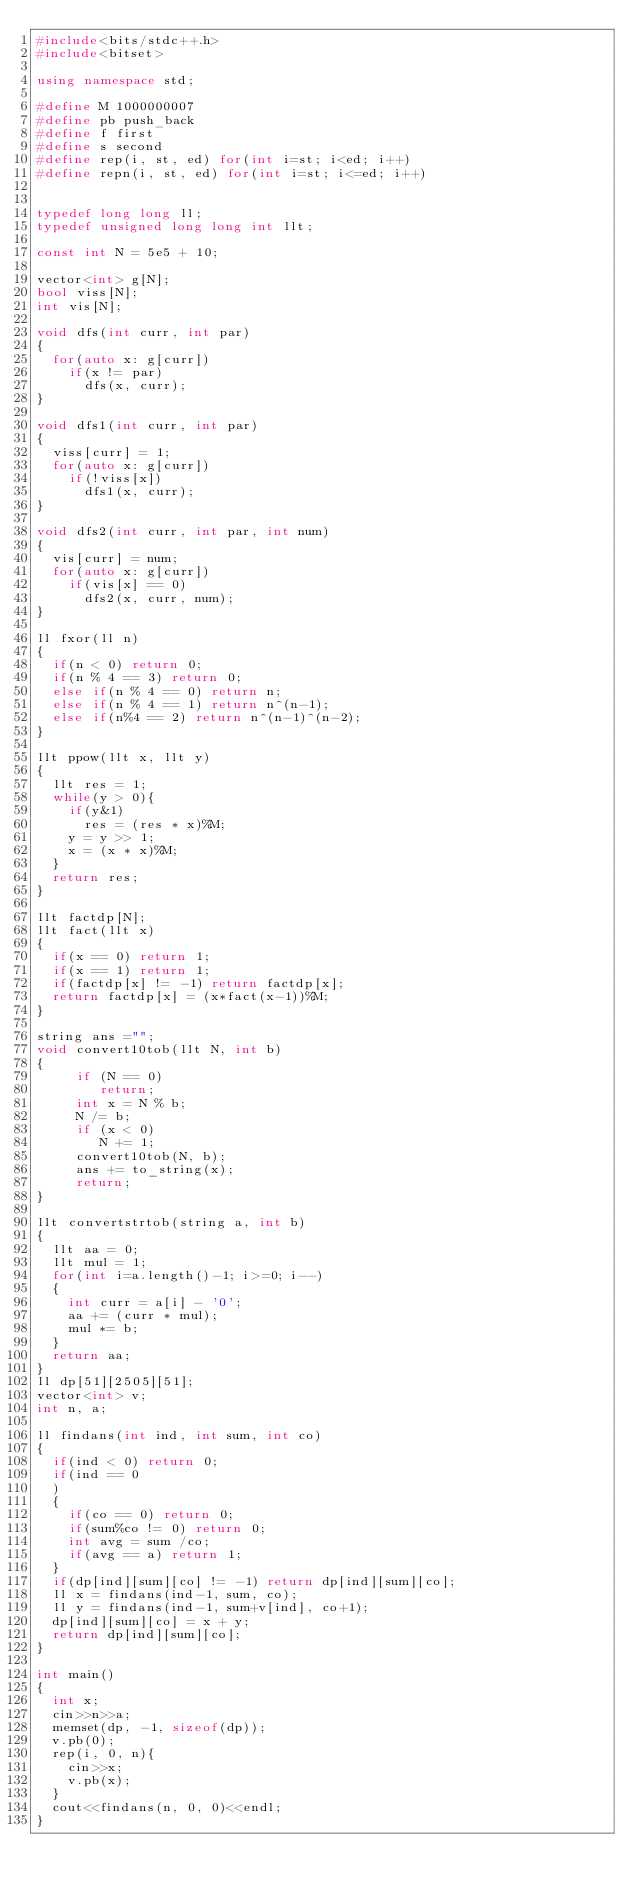Convert code to text. <code><loc_0><loc_0><loc_500><loc_500><_C++_>#include<bits/stdc++.h>
#include<bitset>

using namespace std;

#define M 1000000007
#define pb push_back
#define f first
#define s second
#define rep(i, st, ed) for(int i=st; i<ed; i++)
#define repn(i, st, ed) for(int i=st; i<=ed; i++)


typedef long long ll;
typedef unsigned long long int llt;

const int N = 5e5 + 10;

vector<int> g[N];
bool viss[N];
int vis[N];

void dfs(int curr, int par)
{
  for(auto x: g[curr])
    if(x != par)
      dfs(x, curr);
}

void dfs1(int curr, int par)
{
  viss[curr] = 1;
  for(auto x: g[curr])
    if(!viss[x])
      dfs1(x, curr);
}

void dfs2(int curr, int par, int num)
{
  vis[curr] = num;
  for(auto x: g[curr])
    if(vis[x] == 0)
      dfs2(x, curr, num);
}

ll fxor(ll n)
{
  if(n < 0) return 0;
  if(n % 4 == 3) return 0;
  else if(n % 4 == 0) return n;
  else if(n % 4 == 1) return n^(n-1);
  else if(n%4 == 2) return n^(n-1)^(n-2);
}

llt ppow(llt x, llt y)
{
  llt res = 1;
  while(y > 0){
    if(y&1)
      res = (res * x)%M;
    y = y >> 1;
    x = (x * x)%M;
  }
  return res;
}

llt factdp[N];
llt fact(llt x)
{
  if(x == 0) return 1;
  if(x == 1) return 1;
  if(factdp[x] != -1) return factdp[x];
  return factdp[x] = (x*fact(x-1))%M;
}

string ans ="";
void convert10tob(llt N, int b)
{
     if (N == 0)
        return;
     int x = N % b;
     N /= b;
     if (x < 0)
        N += 1;
     convert10tob(N, b);
     ans += to_string(x);
     return;
}

llt convertstrtob(string a, int b)
{
  llt aa = 0;
  llt mul = 1;
  for(int i=a.length()-1; i>=0; i--)
  {
    int curr = a[i] - '0';
    aa += (curr * mul);
    mul *= b;
  }
  return aa;
}
ll dp[51][2505][51];
vector<int> v;
int n, a;

ll findans(int ind, int sum, int co)
{
  if(ind < 0) return 0;
  if(ind == 0
  )
  {
    if(co == 0) return 0;
    if(sum%co != 0) return 0;
    int avg = sum /co;
    if(avg == a) return 1;
  }
  if(dp[ind][sum][co] != -1) return dp[ind][sum][co];
  ll x = findans(ind-1, sum, co);
  ll y = findans(ind-1, sum+v[ind], co+1);
  dp[ind][sum][co] = x + y;
  return dp[ind][sum][co];
}

int main()
{
  int x;
  cin>>n>>a;
  memset(dp, -1, sizeof(dp));
  v.pb(0);
  rep(i, 0, n){
    cin>>x;
    v.pb(x);
  }
  cout<<findans(n, 0, 0)<<endl;
}
</code> 